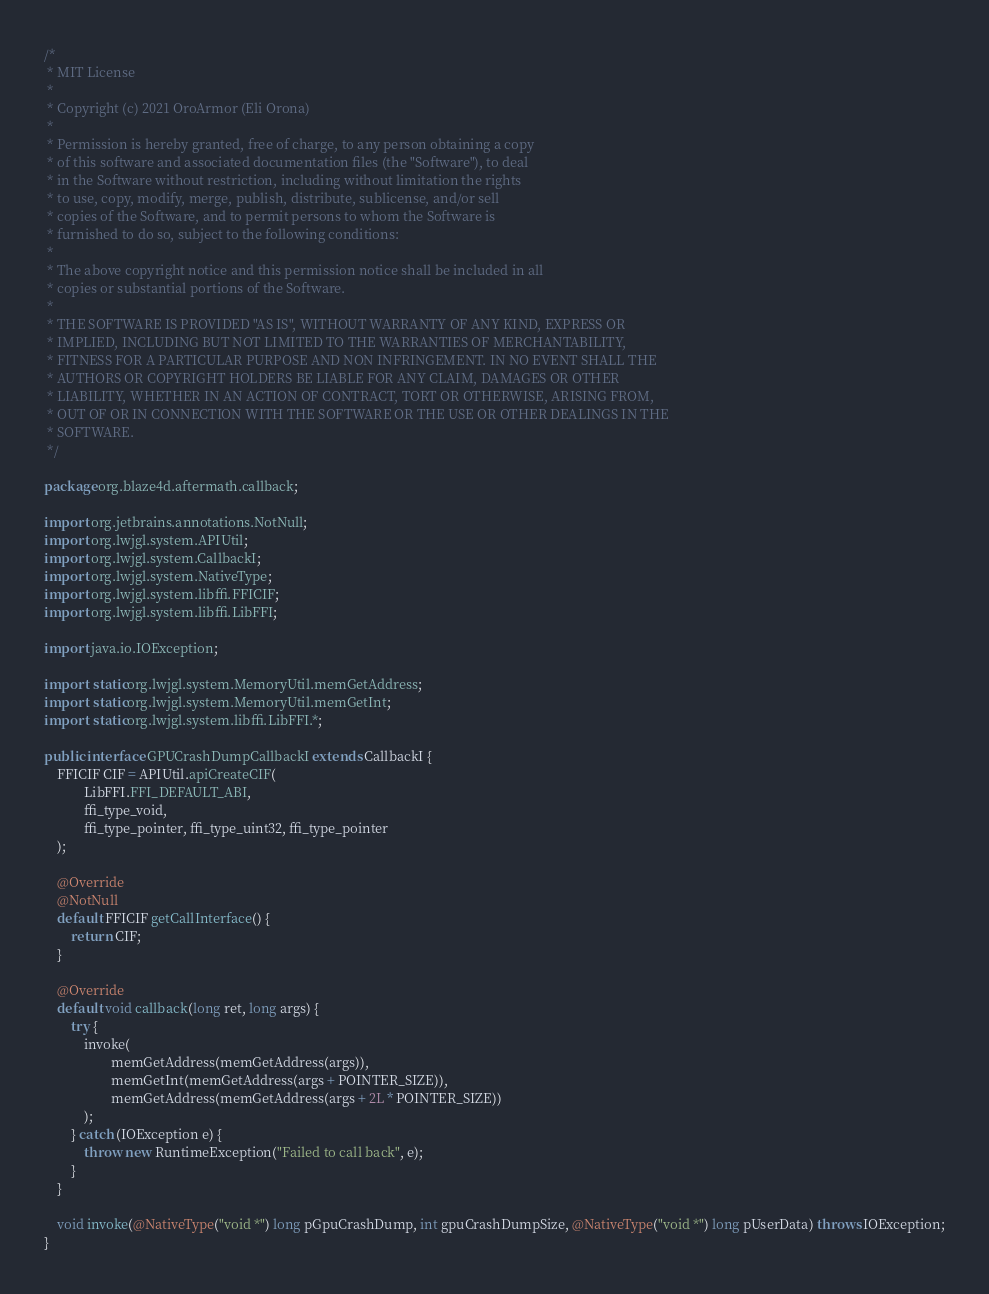<code> <loc_0><loc_0><loc_500><loc_500><_Java_>/*
 * MIT License
 *
 * Copyright (c) 2021 OroArmor (Eli Orona)
 *
 * Permission is hereby granted, free of charge, to any person obtaining a copy
 * of this software and associated documentation files (the "Software"), to deal
 * in the Software without restriction, including without limitation the rights
 * to use, copy, modify, merge, publish, distribute, sublicense, and/or sell
 * copies of the Software, and to permit persons to whom the Software is
 * furnished to do so, subject to the following conditions:
 *
 * The above copyright notice and this permission notice shall be included in all
 * copies or substantial portions of the Software.
 *
 * THE SOFTWARE IS PROVIDED "AS IS", WITHOUT WARRANTY OF ANY KIND, EXPRESS OR
 * IMPLIED, INCLUDING BUT NOT LIMITED TO THE WARRANTIES OF MERCHANTABILITY,
 * FITNESS FOR A PARTICULAR PURPOSE AND NON INFRINGEMENT. IN NO EVENT SHALL THE
 * AUTHORS OR COPYRIGHT HOLDERS BE LIABLE FOR ANY CLAIM, DAMAGES OR OTHER
 * LIABILITY, WHETHER IN AN ACTION OF CONTRACT, TORT OR OTHERWISE, ARISING FROM,
 * OUT OF OR IN CONNECTION WITH THE SOFTWARE OR THE USE OR OTHER DEALINGS IN THE
 * SOFTWARE.
 */

package org.blaze4d.aftermath.callback;

import org.jetbrains.annotations.NotNull;
import org.lwjgl.system.APIUtil;
import org.lwjgl.system.CallbackI;
import org.lwjgl.system.NativeType;
import org.lwjgl.system.libffi.FFICIF;
import org.lwjgl.system.libffi.LibFFI;

import java.io.IOException;

import static org.lwjgl.system.MemoryUtil.memGetAddress;
import static org.lwjgl.system.MemoryUtil.memGetInt;
import static org.lwjgl.system.libffi.LibFFI.*;

public interface GPUCrashDumpCallbackI extends CallbackI {
    FFICIF CIF = APIUtil.apiCreateCIF(
            LibFFI.FFI_DEFAULT_ABI,
            ffi_type_void,
            ffi_type_pointer, ffi_type_uint32, ffi_type_pointer
    );

    @Override
    @NotNull
    default FFICIF getCallInterface() {
        return CIF;
    }

    @Override
    default void callback(long ret, long args) {
        try {
            invoke(
                    memGetAddress(memGetAddress(args)),
                    memGetInt(memGetAddress(args + POINTER_SIZE)),
                    memGetAddress(memGetAddress(args + 2L * POINTER_SIZE))
            );
        } catch (IOException e) {
            throw new RuntimeException("Failed to call back", e);
        }
    }

    void invoke(@NativeType("void *") long pGpuCrashDump, int gpuCrashDumpSize, @NativeType("void *") long pUserData) throws IOException;
}
</code> 